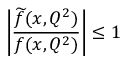Convert formula to latex. <formula><loc_0><loc_0><loc_500><loc_500>\left | \frac { { \widetilde { f } } ( x , Q ^ { 2 } ) } { f ( x , Q ^ { 2 } ) } \right | \leq 1</formula> 